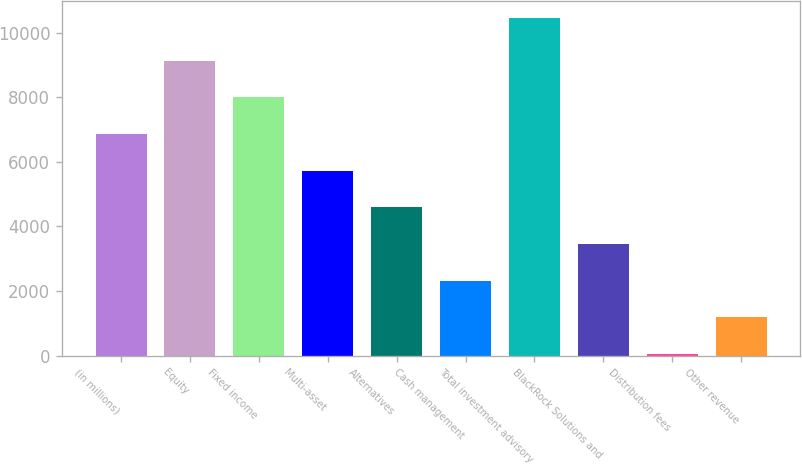<chart> <loc_0><loc_0><loc_500><loc_500><bar_chart><fcel>(in millions)<fcel>Equity<fcel>Fixed income<fcel>Multi-asset<fcel>Alternatives<fcel>Cash management<fcel>Total investment advisory<fcel>BlackRock Solutions and<fcel>Distribution fees<fcel>Other revenue<nl><fcel>6862.6<fcel>9131.8<fcel>7997.2<fcel>5728<fcel>4593.4<fcel>2324.2<fcel>10461<fcel>3458.8<fcel>55<fcel>1189.6<nl></chart> 